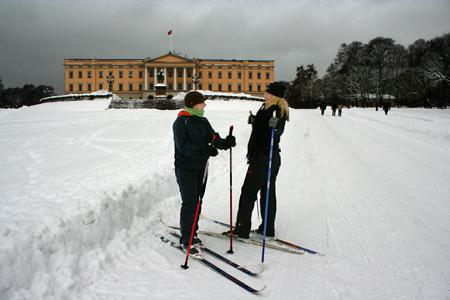Question: what color are their ski poles?
Choices:
A. Orange.
B. Tan.
C. Green.
D. Red and blue.
Answer with the letter. Answer: D Question: what is that building?
Choices:
A. The ski lodge.
B. A spa.
C. A court room.
D. A nature center.
Answer with the letter. Answer: A Question: why do they have skis on?
Choices:
A. They are going skiing.
B. Posing for a picture.
C. Exercising.
D. For the fun of it.
Answer with the letter. Answer: A Question: who is talking?
Choices:
A. The clown.
B. The man and the woman.
C. The chef.
D. The President.
Answer with the letter. Answer: B Question: when did they go skiing?
Choices:
A. During the day.
B. After the wedding.
C. After the bar.
D. During the snow storm.
Answer with the letter. Answer: A 